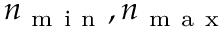Convert formula to latex. <formula><loc_0><loc_0><loc_500><loc_500>n _ { m i n } , n _ { m a x }</formula> 